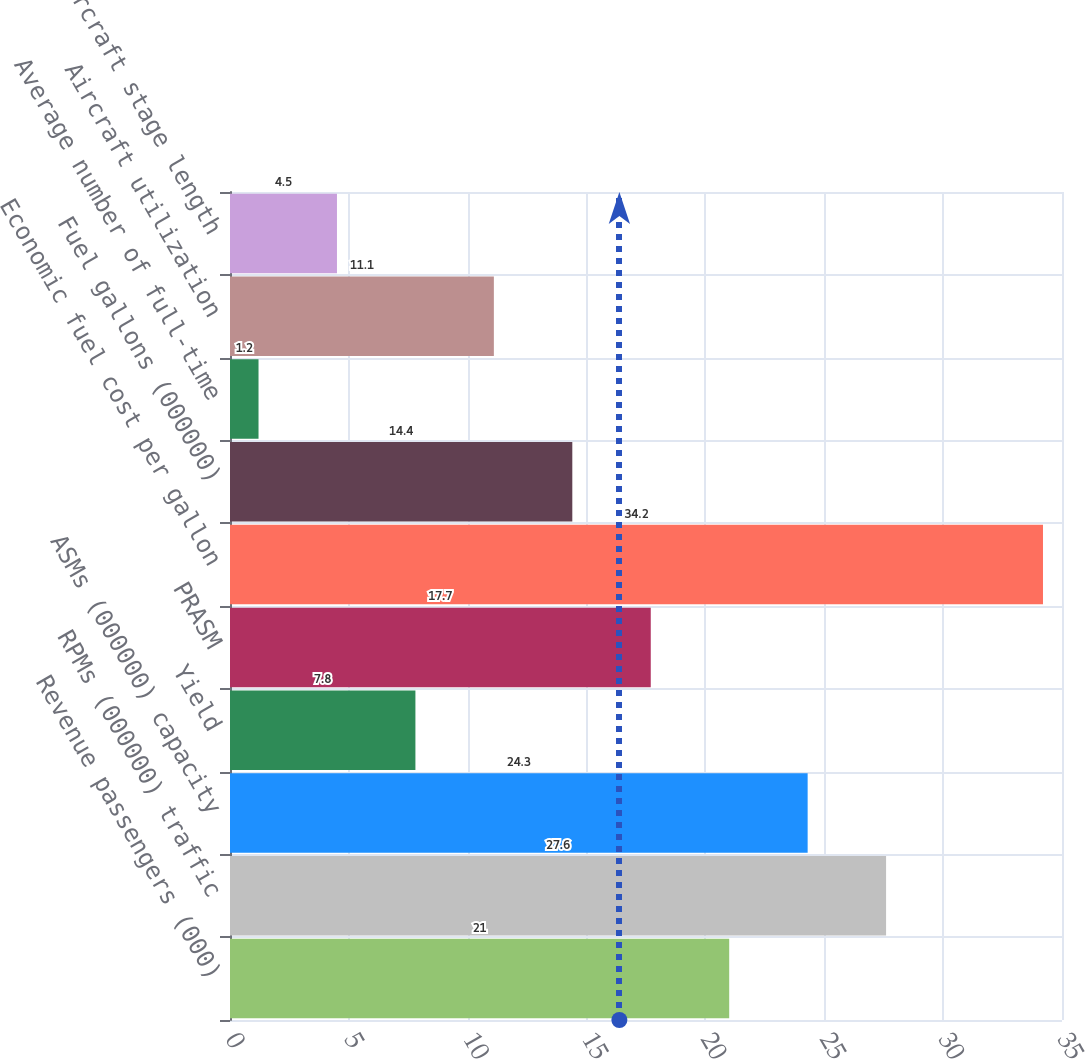Convert chart. <chart><loc_0><loc_0><loc_500><loc_500><bar_chart><fcel>Revenue passengers (000)<fcel>RPMs (000000) traffic<fcel>ASMs (000000) capacity<fcel>Yield<fcel>PRASM<fcel>Economic fuel cost per gallon<fcel>Fuel gallons (000000)<fcel>Average number of full-time<fcel>Aircraft utilization<fcel>Average aircraft stage length<nl><fcel>21<fcel>27.6<fcel>24.3<fcel>7.8<fcel>17.7<fcel>34.2<fcel>14.4<fcel>1.2<fcel>11.1<fcel>4.5<nl></chart> 